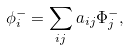Convert formula to latex. <formula><loc_0><loc_0><loc_500><loc_500>\phi _ { i } ^ { - } = \sum _ { i j } a _ { i j } \Phi _ { j } ^ { - } ,</formula> 